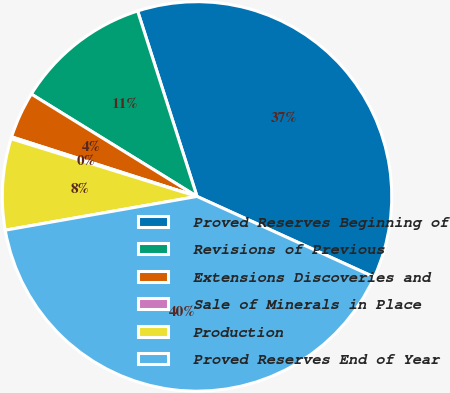Convert chart to OTSL. <chart><loc_0><loc_0><loc_500><loc_500><pie_chart><fcel>Proved Reserves Beginning of<fcel>Revisions of Previous<fcel>Extensions Discoveries and<fcel>Sale of Minerals in Place<fcel>Production<fcel>Proved Reserves End of Year<nl><fcel>36.73%<fcel>11.26%<fcel>3.86%<fcel>0.16%<fcel>7.56%<fcel>40.43%<nl></chart> 